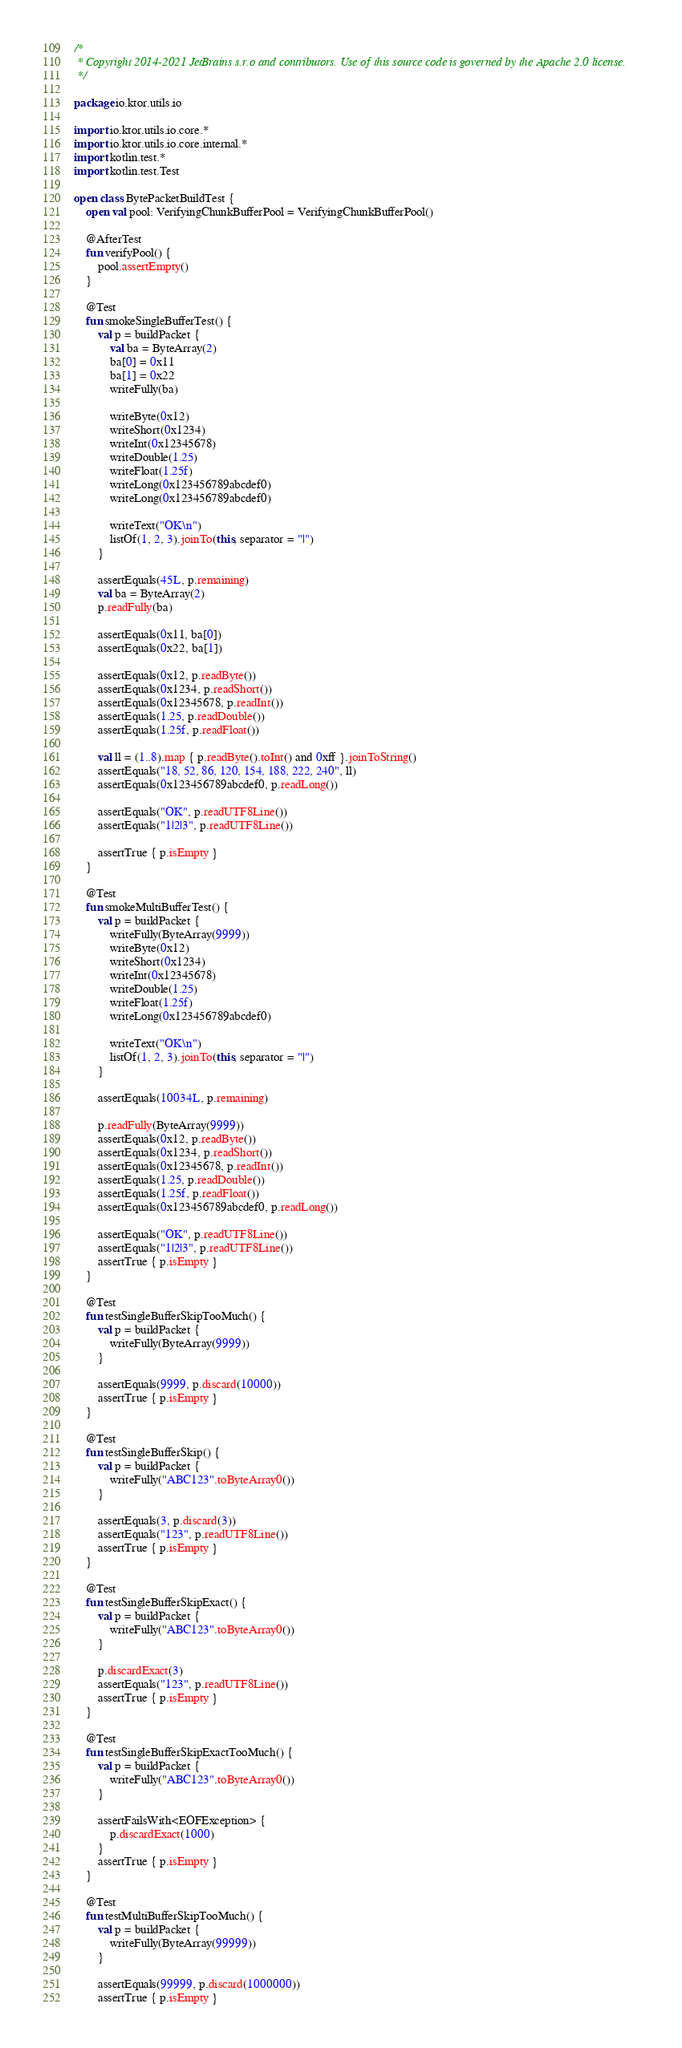Convert code to text. <code><loc_0><loc_0><loc_500><loc_500><_Kotlin_>/*
 * Copyright 2014-2021 JetBrains s.r.o and contributors. Use of this source code is governed by the Apache 2.0 license.
 */

package io.ktor.utils.io

import io.ktor.utils.io.core.*
import io.ktor.utils.io.core.internal.*
import kotlin.test.*
import kotlin.test.Test

open class BytePacketBuildTest {
    open val pool: VerifyingChunkBufferPool = VerifyingChunkBufferPool()

    @AfterTest
    fun verifyPool() {
        pool.assertEmpty()
    }

    @Test
    fun smokeSingleBufferTest() {
        val p = buildPacket {
            val ba = ByteArray(2)
            ba[0] = 0x11
            ba[1] = 0x22
            writeFully(ba)

            writeByte(0x12)
            writeShort(0x1234)
            writeInt(0x12345678)
            writeDouble(1.25)
            writeFloat(1.25f)
            writeLong(0x123456789abcdef0)
            writeLong(0x123456789abcdef0)

            writeText("OK\n")
            listOf(1, 2, 3).joinTo(this, separator = "|")
        }

        assertEquals(45L, p.remaining)
        val ba = ByteArray(2)
        p.readFully(ba)

        assertEquals(0x11, ba[0])
        assertEquals(0x22, ba[1])

        assertEquals(0x12, p.readByte())
        assertEquals(0x1234, p.readShort())
        assertEquals(0x12345678, p.readInt())
        assertEquals(1.25, p.readDouble())
        assertEquals(1.25f, p.readFloat())

        val ll = (1..8).map { p.readByte().toInt() and 0xff }.joinToString()
        assertEquals("18, 52, 86, 120, 154, 188, 222, 240", ll)
        assertEquals(0x123456789abcdef0, p.readLong())

        assertEquals("OK", p.readUTF8Line())
        assertEquals("1|2|3", p.readUTF8Line())

        assertTrue { p.isEmpty }
    }

    @Test
    fun smokeMultiBufferTest() {
        val p = buildPacket {
            writeFully(ByteArray(9999))
            writeByte(0x12)
            writeShort(0x1234)
            writeInt(0x12345678)
            writeDouble(1.25)
            writeFloat(1.25f)
            writeLong(0x123456789abcdef0)

            writeText("OK\n")
            listOf(1, 2, 3).joinTo(this, separator = "|")
        }

        assertEquals(10034L, p.remaining)

        p.readFully(ByteArray(9999))
        assertEquals(0x12, p.readByte())
        assertEquals(0x1234, p.readShort())
        assertEquals(0x12345678, p.readInt())
        assertEquals(1.25, p.readDouble())
        assertEquals(1.25f, p.readFloat())
        assertEquals(0x123456789abcdef0, p.readLong())

        assertEquals("OK", p.readUTF8Line())
        assertEquals("1|2|3", p.readUTF8Line())
        assertTrue { p.isEmpty }
    }

    @Test
    fun testSingleBufferSkipTooMuch() {
        val p = buildPacket {
            writeFully(ByteArray(9999))
        }

        assertEquals(9999, p.discard(10000))
        assertTrue { p.isEmpty }
    }

    @Test
    fun testSingleBufferSkip() {
        val p = buildPacket {
            writeFully("ABC123".toByteArray0())
        }

        assertEquals(3, p.discard(3))
        assertEquals("123", p.readUTF8Line())
        assertTrue { p.isEmpty }
    }

    @Test
    fun testSingleBufferSkipExact() {
        val p = buildPacket {
            writeFully("ABC123".toByteArray0())
        }

        p.discardExact(3)
        assertEquals("123", p.readUTF8Line())
        assertTrue { p.isEmpty }
    }

    @Test
    fun testSingleBufferSkipExactTooMuch() {
        val p = buildPacket {
            writeFully("ABC123".toByteArray0())
        }

        assertFailsWith<EOFException> {
            p.discardExact(1000)
        }
        assertTrue { p.isEmpty }
    }

    @Test
    fun testMultiBufferSkipTooMuch() {
        val p = buildPacket {
            writeFully(ByteArray(99999))
        }

        assertEquals(99999, p.discard(1000000))
        assertTrue { p.isEmpty }</code> 